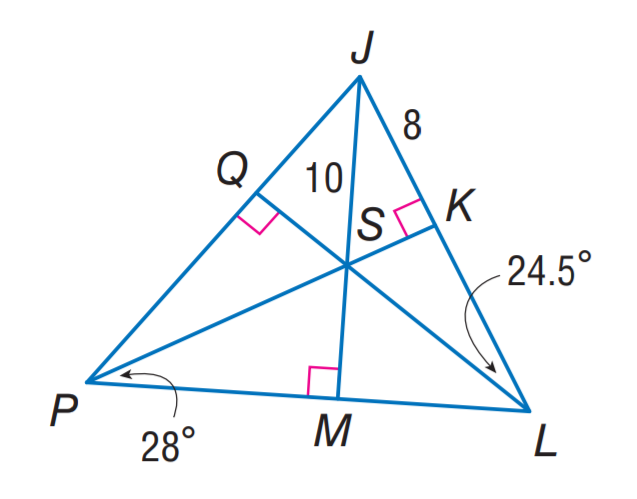Answer the mathemtical geometry problem and directly provide the correct option letter.
Question: Point S is the incenter of \triangle J P L. Find m \angle M P Q.
Choices: A: 24.5 B: 28 C: 49 D: 56 D 